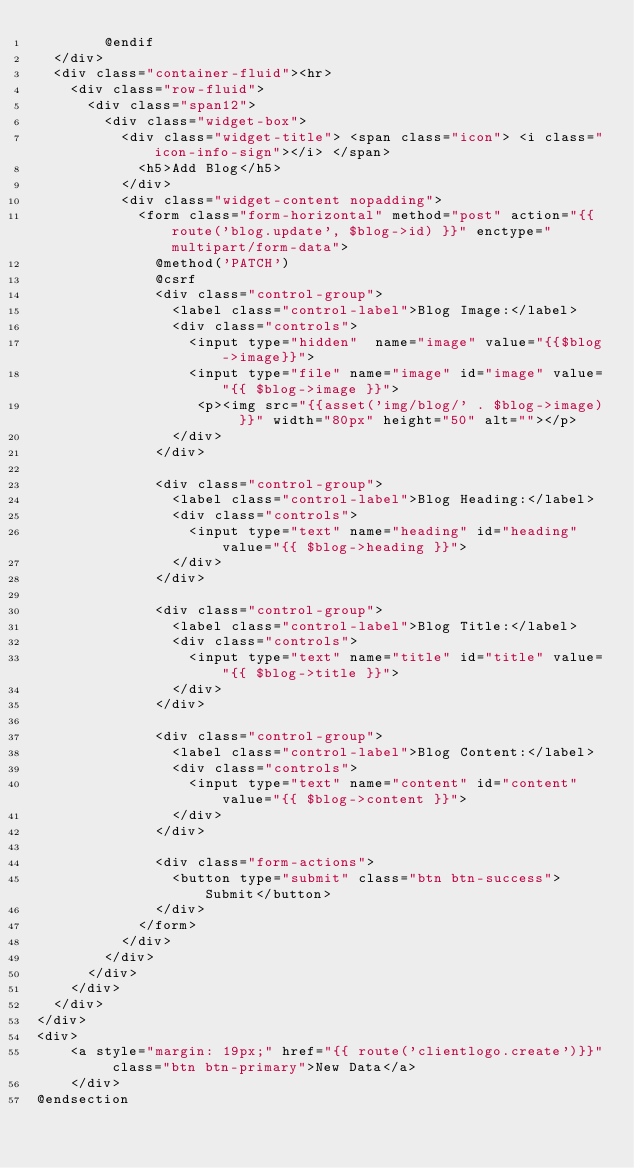Convert code to text. <code><loc_0><loc_0><loc_500><loc_500><_PHP_>        @endif
  </div>
  <div class="container-fluid"><hr>
    <div class="row-fluid">
      <div class="span12">
        <div class="widget-box">
          <div class="widget-title"> <span class="icon"> <i class="icon-info-sign"></i> </span>
            <h5>Add Blog</h5>
          </div>
          <div class="widget-content nopadding">
            <form class="form-horizontal" method="post" action="{{ route('blog.update', $blog->id) }}" enctype="multipart/form-data">
              @method('PATCH')
              @csrf
              <div class="control-group">
                <label class="control-label">Blog Image:</label>
                <div class="controls">
                  <input type="hidden"  name="image" value="{{$blog->image}}">
                  <input type="file" name="image" id="image" value="{{ $blog->image }}">
                   <p><img src="{{asset('img/blog/' . $blog->image) }}" width="80px" height="50" alt=""></p>
                </div>
              </div>

              <div class="control-group">
                <label class="control-label">Blog Heading:</label>
                <div class="controls">
                  <input type="text" name="heading" id="heading" value="{{ $blog->heading }}">
                </div>
              </div>

              <div class="control-group">
                <label class="control-label">Blog Title:</label>
                <div class="controls">
                  <input type="text" name="title" id="title" value="{{ $blog->title }}">
                </div>
              </div>

              <div class="control-group">
                <label class="control-label">Blog Content:</label>
                <div class="controls">
                  <input type="text" name="content" id="content" value="{{ $blog->content }}">
                </div>
              </div>
                
              <div class="form-actions">
                <button type="submit" class="btn btn-success">Submit</button>
              </div>
            </form>
          </div>
        </div>
      </div>
    </div>
  </div>
</div>
<div>
    <a style="margin: 19px;" href="{{ route('clientlogo.create')}}" class="btn btn-primary">New Data</a>
    </div> 
@endsection</code> 